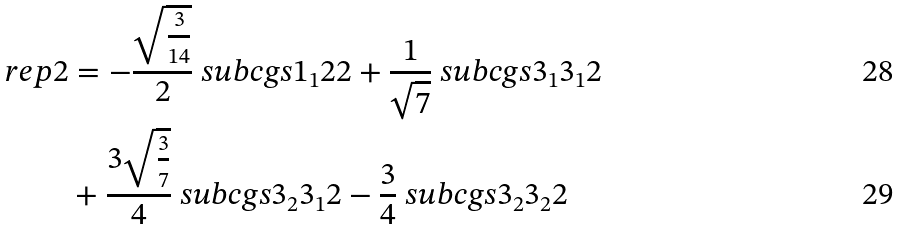Convert formula to latex. <formula><loc_0><loc_0><loc_500><loc_500>\ r e p { 2 } & = - \frac { \sqrt { \frac { 3 } { 1 4 } } } { 2 } \ s u b c g s { 1 _ { 1 } } { 2 } { 2 } + \frac { 1 } { \sqrt { 7 } } \ s u b c g s { 3 _ { 1 } } { 3 _ { 1 } } { 2 } \\ & + \frac { 3 \sqrt { \frac { 3 } { 7 } } } { 4 } \ s u b c g s { 3 _ { 2 } } { 3 _ { 1 } } { 2 } - \frac { 3 } { 4 } \ s u b c g s { 3 _ { 2 } } { 3 _ { 2 } } { 2 }</formula> 